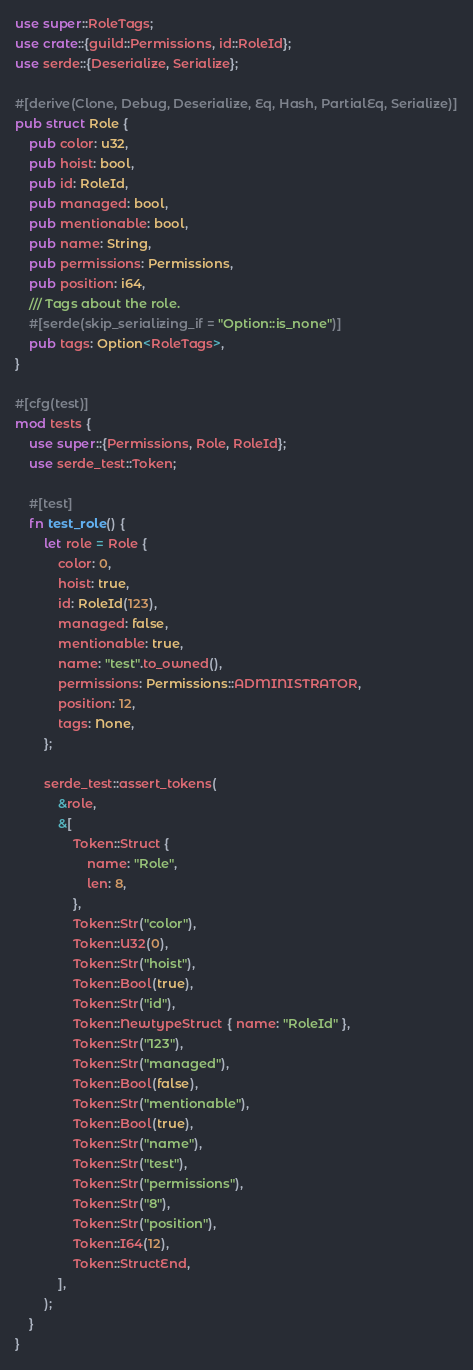<code> <loc_0><loc_0><loc_500><loc_500><_Rust_>use super::RoleTags;
use crate::{guild::Permissions, id::RoleId};
use serde::{Deserialize, Serialize};

#[derive(Clone, Debug, Deserialize, Eq, Hash, PartialEq, Serialize)]
pub struct Role {
    pub color: u32,
    pub hoist: bool,
    pub id: RoleId,
    pub managed: bool,
    pub mentionable: bool,
    pub name: String,
    pub permissions: Permissions,
    pub position: i64,
    /// Tags about the role.
    #[serde(skip_serializing_if = "Option::is_none")]
    pub tags: Option<RoleTags>,
}

#[cfg(test)]
mod tests {
    use super::{Permissions, Role, RoleId};
    use serde_test::Token;

    #[test]
    fn test_role() {
        let role = Role {
            color: 0,
            hoist: true,
            id: RoleId(123),
            managed: false,
            mentionable: true,
            name: "test".to_owned(),
            permissions: Permissions::ADMINISTRATOR,
            position: 12,
            tags: None,
        };

        serde_test::assert_tokens(
            &role,
            &[
                Token::Struct {
                    name: "Role",
                    len: 8,
                },
                Token::Str("color"),
                Token::U32(0),
                Token::Str("hoist"),
                Token::Bool(true),
                Token::Str("id"),
                Token::NewtypeStruct { name: "RoleId" },
                Token::Str("123"),
                Token::Str("managed"),
                Token::Bool(false),
                Token::Str("mentionable"),
                Token::Bool(true),
                Token::Str("name"),
                Token::Str("test"),
                Token::Str("permissions"),
                Token::Str("8"),
                Token::Str("position"),
                Token::I64(12),
                Token::StructEnd,
            ],
        );
    }
}
</code> 